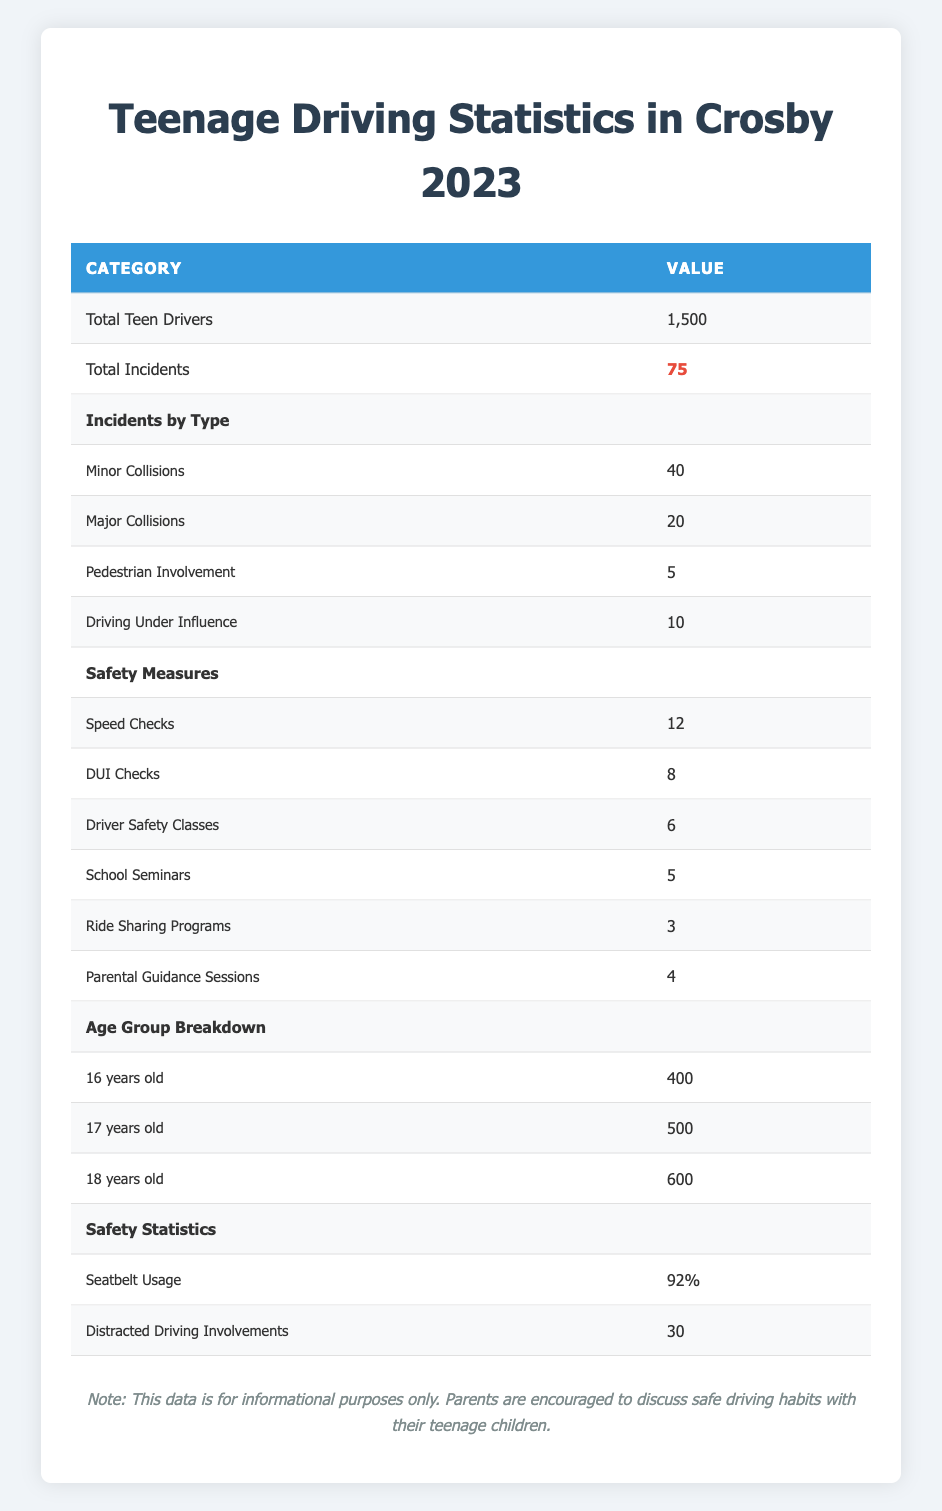What is the total number of teenage drivers in Crosby for 2023? The table clearly shows the total number of teenage drivers listed as 1,500.
Answer: 1,500 How many total incidents involving teenage drivers occurred in 2023? The total incidents involving teenage drivers is noted in the table as 75.
Answer: 75 What is the number of major collisions reported? According to the table, the number of major collisions is specified as 20.
Answer: 20 Is the rate of seatbelt usage among teenage drivers higher than 90%? The table states that seatbelt usage is at 92%, which is indeed higher than 90%.
Answer: Yes How many more minor collisions were there than pedestrian involvements? The table indicates 40 minor collisions and 5 pedestrian involvements, so calculating the difference: 40 - 5 = 35.
Answer: 35 What is the total number of safety measures implemented? To find the total, we add all the safety measures: 12 speed checks + 8 DUI checks + 6 driver safety classes + 5 school seminars + 3 ride-sharing programs + 4 parental guidance sessions = 38 measures total.
Answer: 38 Do teenagers aged 18 have more drivers than those aged 16? The table states there are 600 drivers aged 18 and 400 drivers aged 16, confirming that 18-year-olds have more drivers.
Answer: Yes What percentage of distracted driving involvements is reported for teenage drivers? The table indicates that there are 30 instances of distracted driving involvement, but to find the percentage in relation to total incidents: (30/75)*100 = 40%.
Answer: 40% Which age group has the highest number of drivers? The age group breakdown shows 16-year-olds have 400 drivers, 17-year-olds have 500 drivers, and 18-year-olds have 600 drivers, hence 18-year-olds have the highest number.
Answer: 18 years old How many DUI checks were conducted compared to driver safety classes? The table shows that there were 8 DUI checks and 6 driver safety classes; thus, there were 2 more DUI checks than driver safety classes.
Answer: 2 more DUI checks 